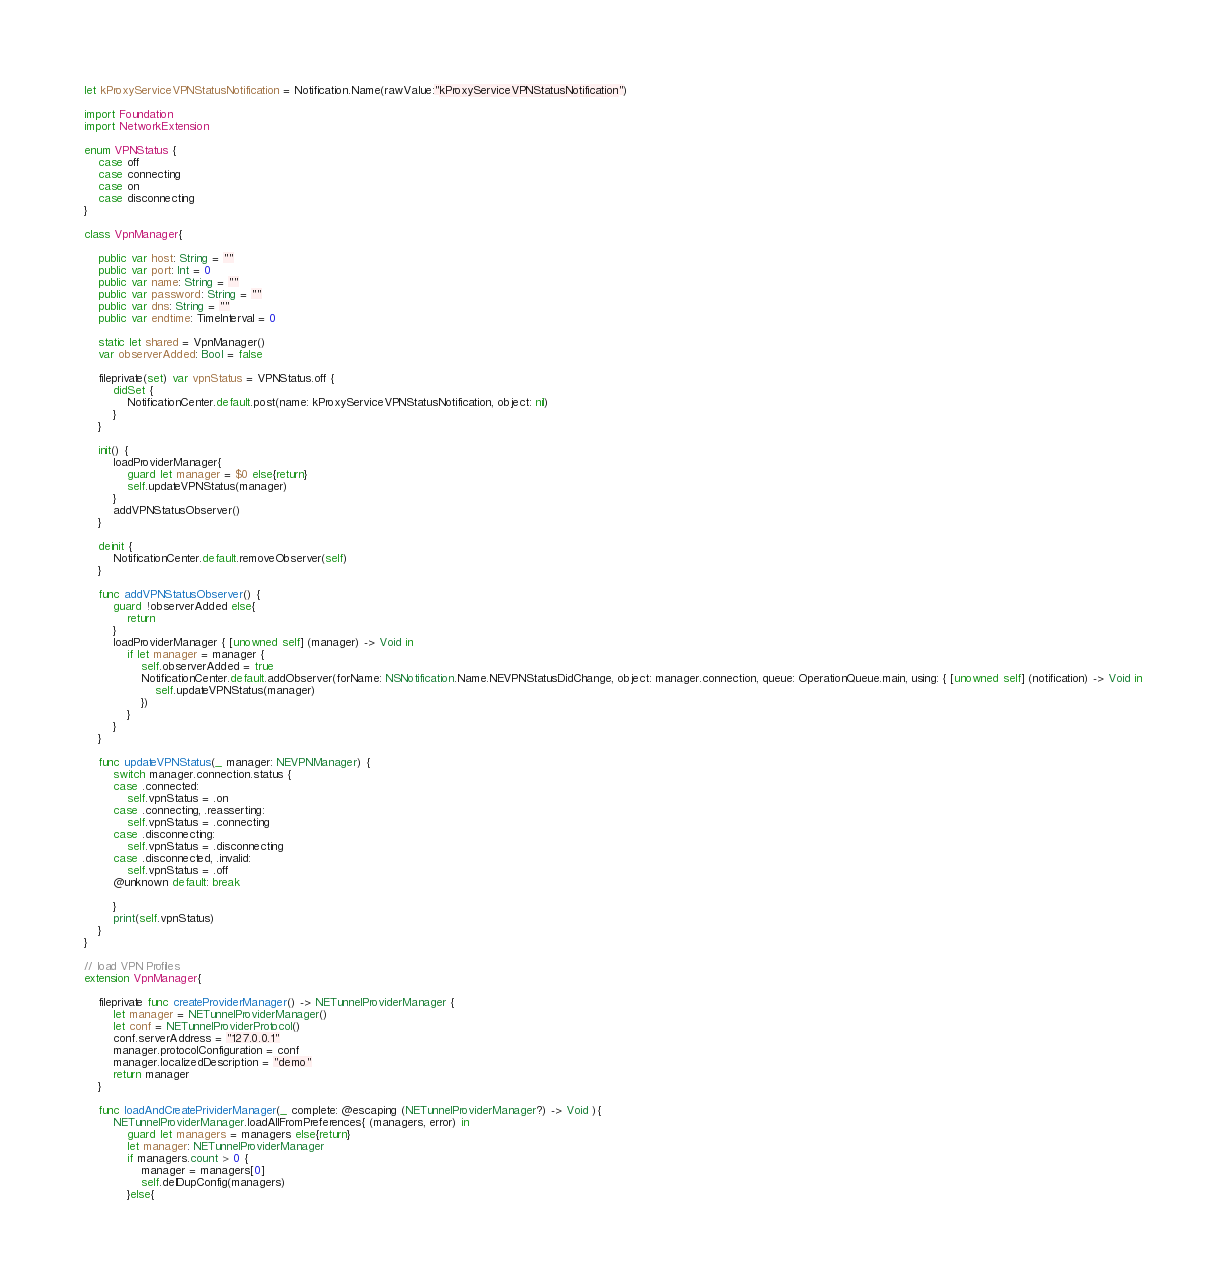Convert code to text. <code><loc_0><loc_0><loc_500><loc_500><_Swift_>let kProxyServiceVPNStatusNotification = Notification.Name(rawValue:"kProxyServiceVPNStatusNotification")

import Foundation
import NetworkExtension

enum VPNStatus {
    case off
    case connecting
    case on
    case disconnecting
}

class VpnManager{
    
    public var host: String = ""
    public var port: Int = 0
    public var name: String = ""
    public var password: String = ""
    public var dns: String = ""
    public var endtime: TimeInterval = 0
    
    static let shared = VpnManager()
    var observerAdded: Bool = false
    
    fileprivate(set) var vpnStatus = VPNStatus.off {
        didSet {
            NotificationCenter.default.post(name: kProxyServiceVPNStatusNotification, object: nil)
        }
    }
    
    init() {
        loadProviderManager{
            guard let manager = $0 else{return}
            self.updateVPNStatus(manager)
        }
        addVPNStatusObserver()
    }
    
    deinit {
        NotificationCenter.default.removeObserver(self)
    }
    
    func addVPNStatusObserver() {
        guard !observerAdded else{
            return
        }
        loadProviderManager { [unowned self] (manager) -> Void in
            if let manager = manager {
                self.observerAdded = true
                NotificationCenter.default.addObserver(forName: NSNotification.Name.NEVPNStatusDidChange, object: manager.connection, queue: OperationQueue.main, using: { [unowned self] (notification) -> Void in
                    self.updateVPNStatus(manager)
                })
            }
        }
    }
    
    func updateVPNStatus(_ manager: NEVPNManager) {
        switch manager.connection.status {
        case .connected:
            self.vpnStatus = .on
        case .connecting, .reasserting:
            self.vpnStatus = .connecting
        case .disconnecting:
            self.vpnStatus = .disconnecting
        case .disconnected, .invalid:
            self.vpnStatus = .off
        @unknown default: break
            
        }
        print(self.vpnStatus)
    }
}

// load VPN Profiles
extension VpnManager{

    fileprivate func createProviderManager() -> NETunnelProviderManager {
        let manager = NETunnelProviderManager()
        let conf = NETunnelProviderProtocol()
        conf.serverAddress = "127.0.0.1"
        manager.protocolConfiguration = conf
        manager.localizedDescription = "demo"
        return manager
    }
    
    func loadAndCreatePrividerManager(_ complete: @escaping (NETunnelProviderManager?) -> Void ){
        NETunnelProviderManager.loadAllFromPreferences{ (managers, error) in
            guard let managers = managers else{return}
            let manager: NETunnelProviderManager
            if managers.count > 0 {
                manager = managers[0]
                self.delDupConfig(managers)
            }else{</code> 